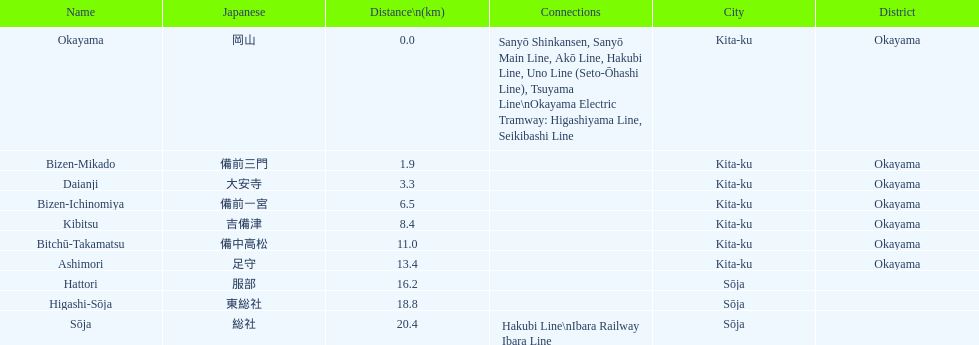Which has a distance less than 3.0 kilometers? Bizen-Mikado. 